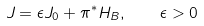Convert formula to latex. <formula><loc_0><loc_0><loc_500><loc_500>J = \epsilon J _ { 0 } + \pi ^ { \ast } H _ { B } , \quad { \epsilon } > 0</formula> 